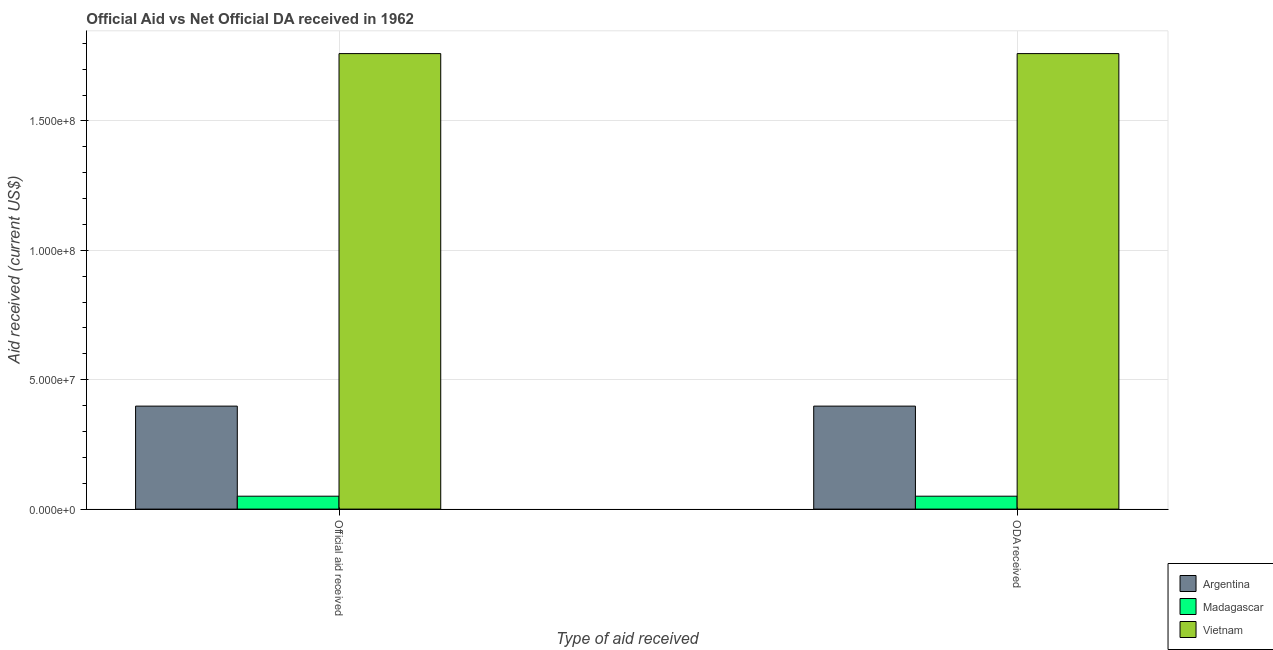How many groups of bars are there?
Give a very brief answer. 2. Are the number of bars per tick equal to the number of legend labels?
Offer a very short reply. Yes. What is the label of the 1st group of bars from the left?
Your answer should be compact. Official aid received. What is the oda received in Madagascar?
Provide a succinct answer. 4.99e+06. Across all countries, what is the maximum oda received?
Give a very brief answer. 1.76e+08. Across all countries, what is the minimum oda received?
Your answer should be compact. 4.99e+06. In which country was the oda received maximum?
Give a very brief answer. Vietnam. In which country was the official aid received minimum?
Provide a short and direct response. Madagascar. What is the total official aid received in the graph?
Your response must be concise. 2.21e+08. What is the difference between the oda received in Argentina and that in Madagascar?
Your answer should be very brief. 3.48e+07. What is the difference between the official aid received in Argentina and the oda received in Vietnam?
Provide a succinct answer. -1.36e+08. What is the average official aid received per country?
Your response must be concise. 7.36e+07. In how many countries, is the oda received greater than 60000000 US$?
Your answer should be very brief. 1. What is the ratio of the oda received in Vietnam to that in Argentina?
Ensure brevity in your answer.  4.42. Is the oda received in Vietnam less than that in Argentina?
Provide a succinct answer. No. In how many countries, is the official aid received greater than the average official aid received taken over all countries?
Provide a succinct answer. 1. What does the 2nd bar from the right in ODA received represents?
Offer a terse response. Madagascar. Are all the bars in the graph horizontal?
Make the answer very short. No. What is the difference between two consecutive major ticks on the Y-axis?
Offer a very short reply. 5.00e+07. Are the values on the major ticks of Y-axis written in scientific E-notation?
Give a very brief answer. Yes. Does the graph contain grids?
Your answer should be compact. Yes. How many legend labels are there?
Ensure brevity in your answer.  3. How are the legend labels stacked?
Provide a short and direct response. Vertical. What is the title of the graph?
Provide a short and direct response. Official Aid vs Net Official DA received in 1962 . What is the label or title of the X-axis?
Provide a short and direct response. Type of aid received. What is the label or title of the Y-axis?
Your answer should be compact. Aid received (current US$). What is the Aid received (current US$) in Argentina in Official aid received?
Your response must be concise. 3.98e+07. What is the Aid received (current US$) in Madagascar in Official aid received?
Ensure brevity in your answer.  4.99e+06. What is the Aid received (current US$) of Vietnam in Official aid received?
Provide a short and direct response. 1.76e+08. What is the Aid received (current US$) of Argentina in ODA received?
Ensure brevity in your answer.  3.98e+07. What is the Aid received (current US$) of Madagascar in ODA received?
Your answer should be compact. 4.99e+06. What is the Aid received (current US$) in Vietnam in ODA received?
Provide a short and direct response. 1.76e+08. Across all Type of aid received, what is the maximum Aid received (current US$) in Argentina?
Give a very brief answer. 3.98e+07. Across all Type of aid received, what is the maximum Aid received (current US$) of Madagascar?
Offer a very short reply. 4.99e+06. Across all Type of aid received, what is the maximum Aid received (current US$) in Vietnam?
Provide a succinct answer. 1.76e+08. Across all Type of aid received, what is the minimum Aid received (current US$) of Argentina?
Keep it short and to the point. 3.98e+07. Across all Type of aid received, what is the minimum Aid received (current US$) in Madagascar?
Your answer should be compact. 4.99e+06. Across all Type of aid received, what is the minimum Aid received (current US$) of Vietnam?
Offer a terse response. 1.76e+08. What is the total Aid received (current US$) of Argentina in the graph?
Give a very brief answer. 7.96e+07. What is the total Aid received (current US$) of Madagascar in the graph?
Your response must be concise. 9.98e+06. What is the total Aid received (current US$) of Vietnam in the graph?
Offer a very short reply. 3.52e+08. What is the difference between the Aid received (current US$) of Argentina in Official aid received and that in ODA received?
Give a very brief answer. 0. What is the difference between the Aid received (current US$) in Madagascar in Official aid received and that in ODA received?
Your response must be concise. 0. What is the difference between the Aid received (current US$) of Vietnam in Official aid received and that in ODA received?
Your answer should be compact. 0. What is the difference between the Aid received (current US$) in Argentina in Official aid received and the Aid received (current US$) in Madagascar in ODA received?
Keep it short and to the point. 3.48e+07. What is the difference between the Aid received (current US$) of Argentina in Official aid received and the Aid received (current US$) of Vietnam in ODA received?
Your answer should be compact. -1.36e+08. What is the difference between the Aid received (current US$) in Madagascar in Official aid received and the Aid received (current US$) in Vietnam in ODA received?
Ensure brevity in your answer.  -1.71e+08. What is the average Aid received (current US$) in Argentina per Type of aid received?
Your answer should be compact. 3.98e+07. What is the average Aid received (current US$) in Madagascar per Type of aid received?
Keep it short and to the point. 4.99e+06. What is the average Aid received (current US$) of Vietnam per Type of aid received?
Offer a very short reply. 1.76e+08. What is the difference between the Aid received (current US$) in Argentina and Aid received (current US$) in Madagascar in Official aid received?
Provide a succinct answer. 3.48e+07. What is the difference between the Aid received (current US$) of Argentina and Aid received (current US$) of Vietnam in Official aid received?
Provide a succinct answer. -1.36e+08. What is the difference between the Aid received (current US$) in Madagascar and Aid received (current US$) in Vietnam in Official aid received?
Make the answer very short. -1.71e+08. What is the difference between the Aid received (current US$) of Argentina and Aid received (current US$) of Madagascar in ODA received?
Keep it short and to the point. 3.48e+07. What is the difference between the Aid received (current US$) in Argentina and Aid received (current US$) in Vietnam in ODA received?
Your answer should be very brief. -1.36e+08. What is the difference between the Aid received (current US$) of Madagascar and Aid received (current US$) of Vietnam in ODA received?
Keep it short and to the point. -1.71e+08. What is the ratio of the Aid received (current US$) of Argentina in Official aid received to that in ODA received?
Keep it short and to the point. 1. What is the ratio of the Aid received (current US$) in Vietnam in Official aid received to that in ODA received?
Offer a terse response. 1. What is the difference between the highest and the second highest Aid received (current US$) in Madagascar?
Offer a very short reply. 0. What is the difference between the highest and the second highest Aid received (current US$) in Vietnam?
Give a very brief answer. 0. What is the difference between the highest and the lowest Aid received (current US$) in Argentina?
Offer a very short reply. 0. What is the difference between the highest and the lowest Aid received (current US$) of Vietnam?
Your answer should be very brief. 0. 